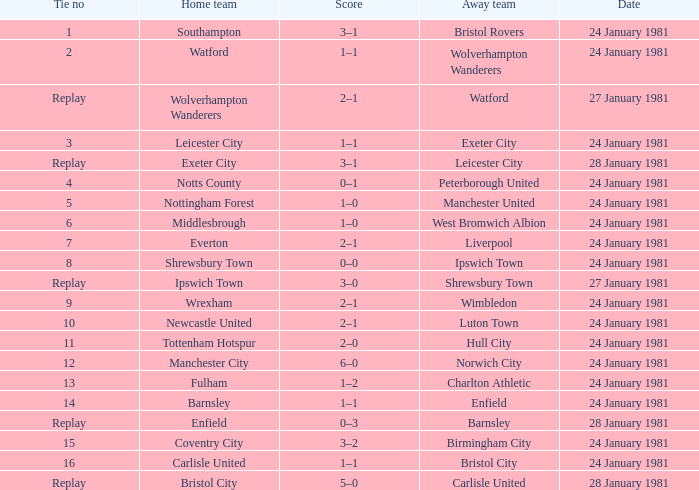When liverpool is the away team, who is the home team? Everton. 